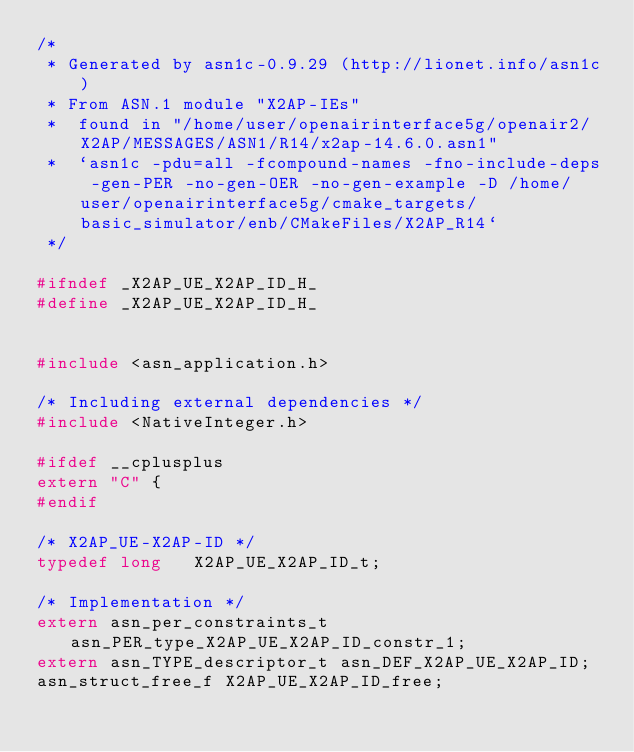<code> <loc_0><loc_0><loc_500><loc_500><_C_>/*
 * Generated by asn1c-0.9.29 (http://lionet.info/asn1c)
 * From ASN.1 module "X2AP-IEs"
 * 	found in "/home/user/openairinterface5g/openair2/X2AP/MESSAGES/ASN1/R14/x2ap-14.6.0.asn1"
 * 	`asn1c -pdu=all -fcompound-names -fno-include-deps -gen-PER -no-gen-OER -no-gen-example -D /home/user/openairinterface5g/cmake_targets/basic_simulator/enb/CMakeFiles/X2AP_R14`
 */

#ifndef	_X2AP_UE_X2AP_ID_H_
#define	_X2AP_UE_X2AP_ID_H_


#include <asn_application.h>

/* Including external dependencies */
#include <NativeInteger.h>

#ifdef __cplusplus
extern "C" {
#endif

/* X2AP_UE-X2AP-ID */
typedef long	 X2AP_UE_X2AP_ID_t;

/* Implementation */
extern asn_per_constraints_t asn_PER_type_X2AP_UE_X2AP_ID_constr_1;
extern asn_TYPE_descriptor_t asn_DEF_X2AP_UE_X2AP_ID;
asn_struct_free_f X2AP_UE_X2AP_ID_free;</code> 